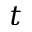<formula> <loc_0><loc_0><loc_500><loc_500>t</formula> 